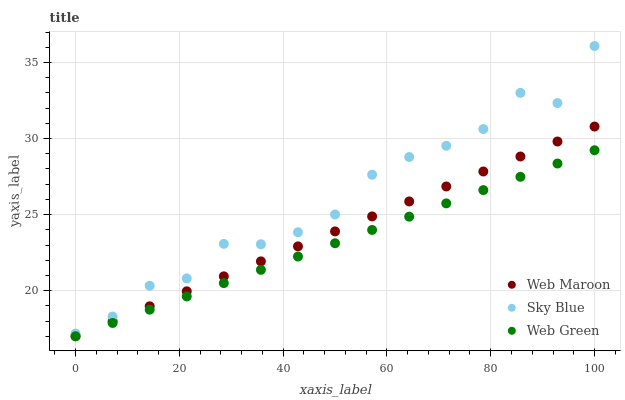Does Web Green have the minimum area under the curve?
Answer yes or no. Yes. Does Sky Blue have the maximum area under the curve?
Answer yes or no. Yes. Does Web Maroon have the minimum area under the curve?
Answer yes or no. No. Does Web Maroon have the maximum area under the curve?
Answer yes or no. No. Is Web Green the smoothest?
Answer yes or no. Yes. Is Sky Blue the roughest?
Answer yes or no. Yes. Is Web Maroon the smoothest?
Answer yes or no. No. Is Web Maroon the roughest?
Answer yes or no. No. Does Web Maroon have the lowest value?
Answer yes or no. Yes. Does Sky Blue have the highest value?
Answer yes or no. Yes. Does Web Maroon have the highest value?
Answer yes or no. No. Is Web Green less than Sky Blue?
Answer yes or no. Yes. Is Sky Blue greater than Web Green?
Answer yes or no. Yes. Does Web Green intersect Web Maroon?
Answer yes or no. Yes. Is Web Green less than Web Maroon?
Answer yes or no. No. Is Web Green greater than Web Maroon?
Answer yes or no. No. Does Web Green intersect Sky Blue?
Answer yes or no. No. 